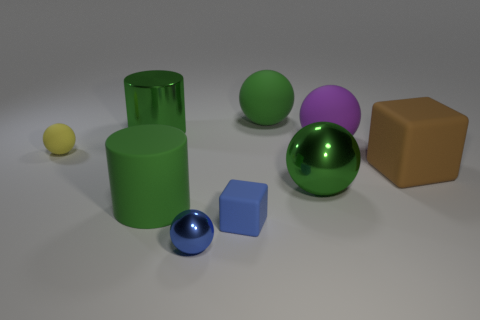Subtract 1 balls. How many balls are left? 4 Subtract all blocks. How many objects are left? 7 Subtract all yellow cubes. Subtract all tiny yellow things. How many objects are left? 8 Add 4 big brown rubber blocks. How many big brown rubber blocks are left? 5 Add 9 small yellow metallic balls. How many small yellow metallic balls exist? 9 Subtract 2 green cylinders. How many objects are left? 7 